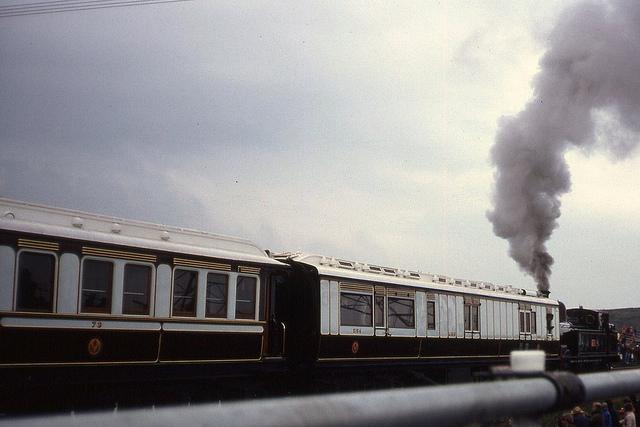Is this trains running?
Be succinct. Yes. How many cards do you see?
Be succinct. 2. Is there smoke?
Concise answer only. Yes. 